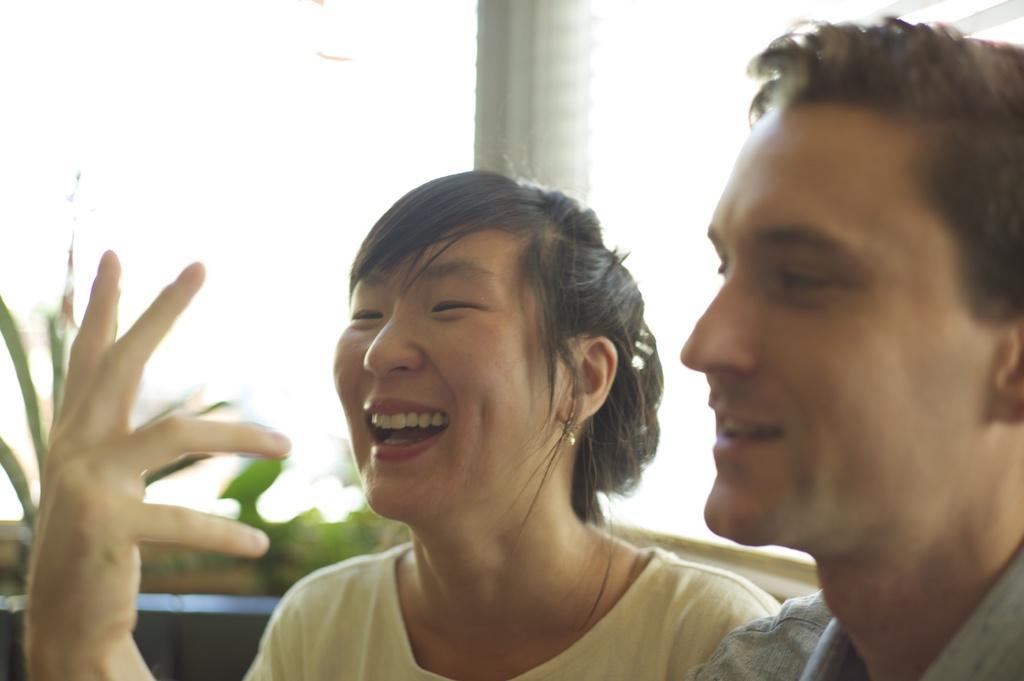In one or two sentences, can you explain what this image depicts? In this image we can see two persons. Behind the persons we can see a pillar. The background of the image is blurred. 